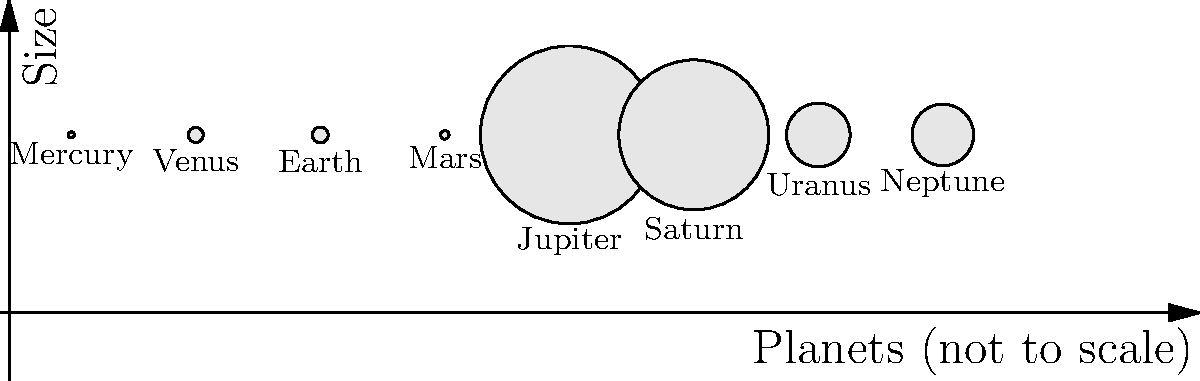As a museum curator planning an exhibition on the solar system, you need to create a scaled model of the planets. Based on the diagram showing the relative sizes of planets, which planet would require the most space and materials to accurately represent in your exhibition, and approximately how many times larger would it be compared to Earth? To answer this question, we need to follow these steps:

1. Identify the largest planet in the diagram:
   From the diagram, we can see that Jupiter is the largest planet.

2. Compare Jupiter's size to Earth's size:
   Jupiter's diameter: 142,984 km
   Earth's diameter: 12,756 km

3. Calculate the ratio of Jupiter's size to Earth's size:
   $\frac{\text{Jupiter's diameter}}{\text{Earth's diameter}} = \frac{142,984}{12,756} \approx 11.21$

4. Round the result to a whole number for practical purposes:
   11.21 rounds to 11

Therefore, Jupiter would require the most space and materials to accurately represent in the exhibition, and it would be approximately 11 times larger than Earth in the scaled model.
Answer: Jupiter, 11 times larger than Earth 